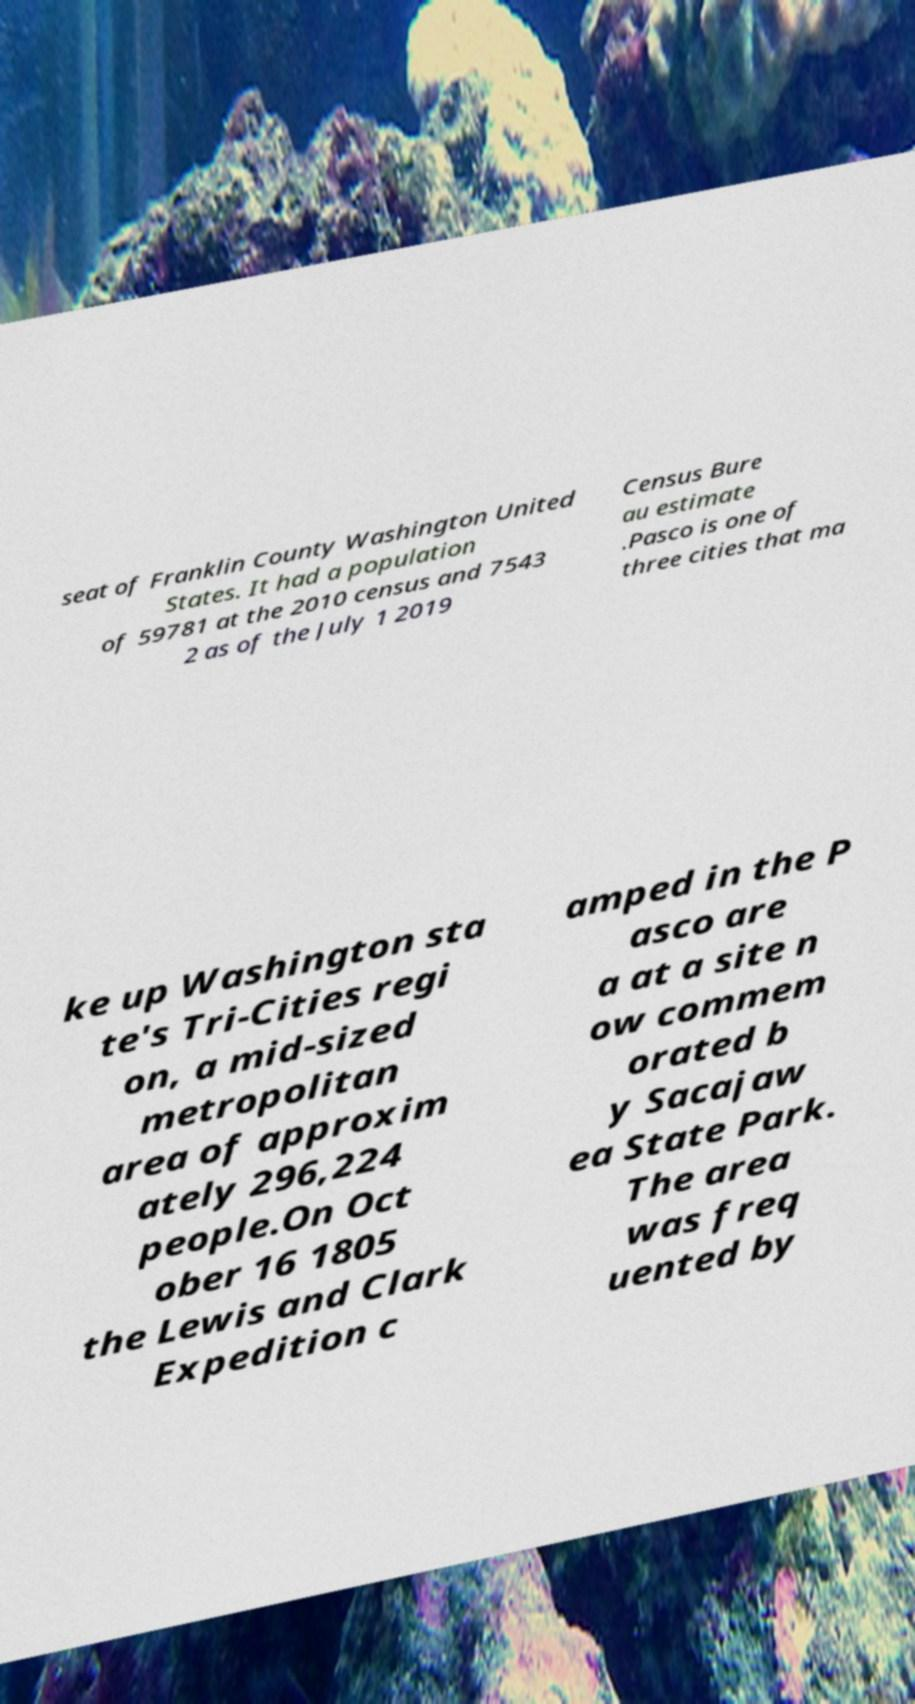Please read and relay the text visible in this image. What does it say? seat of Franklin County Washington United States. It had a population of 59781 at the 2010 census and 7543 2 as of the July 1 2019 Census Bure au estimate .Pasco is one of three cities that ma ke up Washington sta te's Tri-Cities regi on, a mid-sized metropolitan area of approxim ately 296,224 people.On Oct ober 16 1805 the Lewis and Clark Expedition c amped in the P asco are a at a site n ow commem orated b y Sacajaw ea State Park. The area was freq uented by 